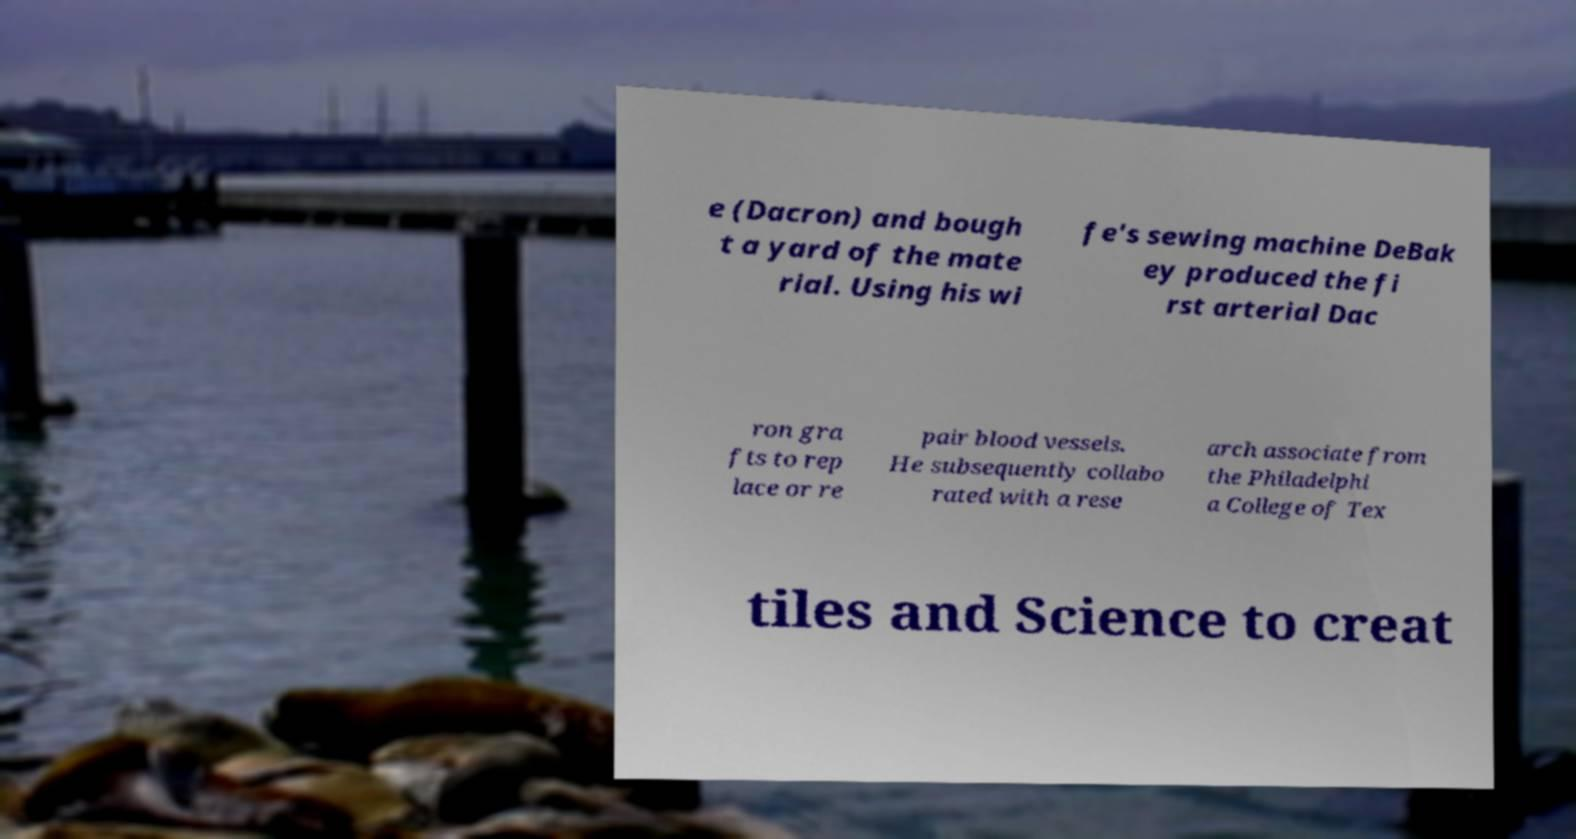Could you assist in decoding the text presented in this image and type it out clearly? e (Dacron) and bough t a yard of the mate rial. Using his wi fe's sewing machine DeBak ey produced the fi rst arterial Dac ron gra fts to rep lace or re pair blood vessels. He subsequently collabo rated with a rese arch associate from the Philadelphi a College of Tex tiles and Science to creat 